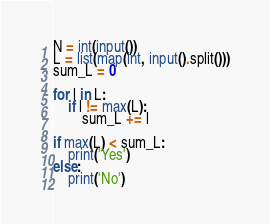Convert code to text. <code><loc_0><loc_0><loc_500><loc_500><_Python_>N = int(input())
L = list(map(int, input().split()))
sum_L = 0

for l in L:
    if l != max(L):
        sum_L += l

if max(L) < sum_L:
    print('Yes')
else:
    print('No')
</code> 